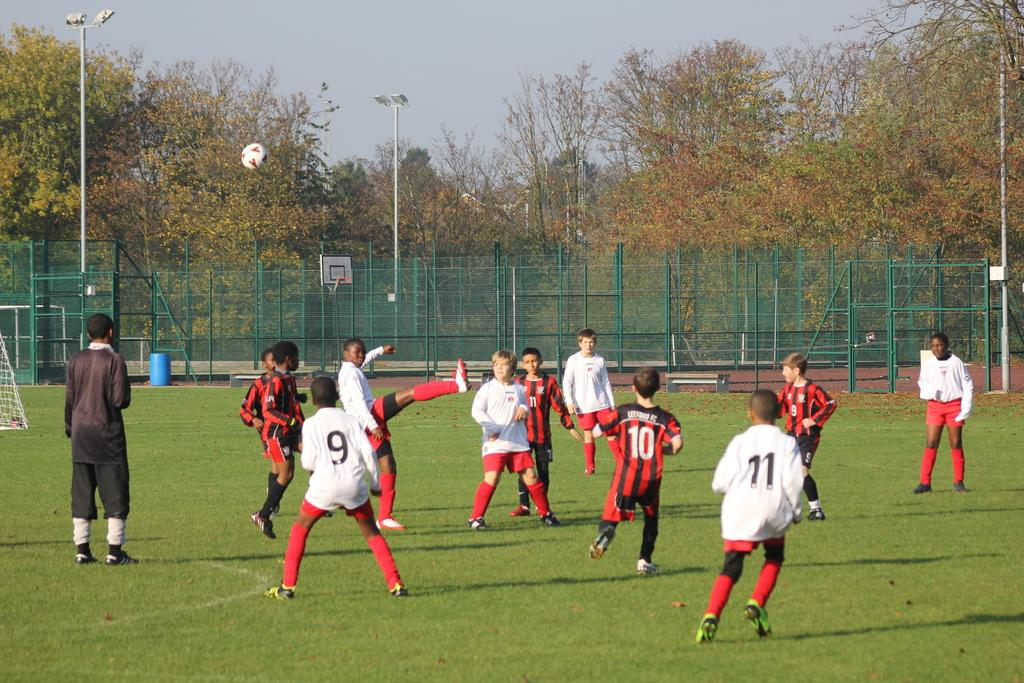<image>
Present a compact description of the photo's key features. Two teams of young boys playing soccer with a boy in a striped jersey and a number 10 is in between kids numbers 9 and 11 